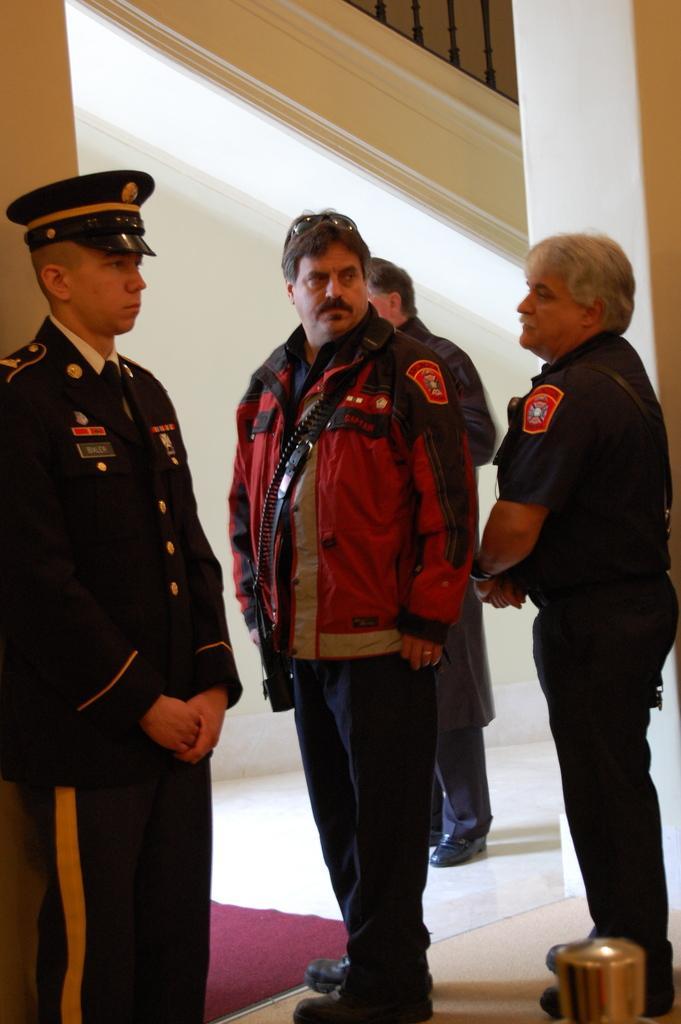How would you summarize this image in a sentence or two? In the picture I can see two policemen standing on the floor. One is on the left side and the other one is on the right side. There is a man in the middle of the picture and he is looking at the policeman on the right side. There is a carpet on the floor. In the background, I can see a person standing on the floor. 